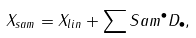Convert formula to latex. <formula><loc_0><loc_0><loc_500><loc_500>X _ { s a m } = X _ { l i n } + \sum S a m ^ { \bullet } D _ { \bullet } ,</formula> 